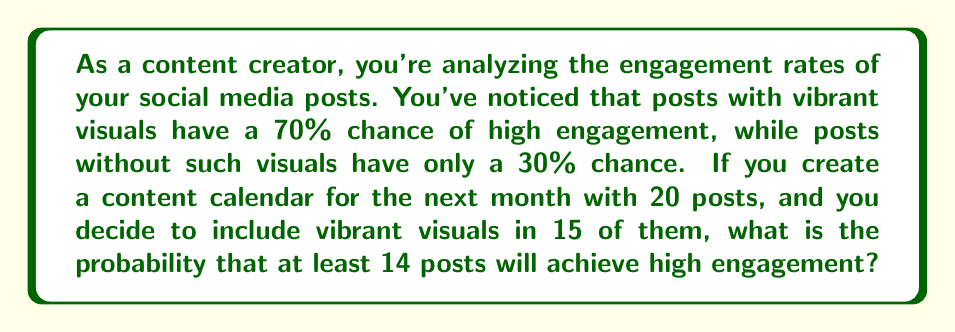Help me with this question. Let's approach this step-by-step using probability theory:

1) First, we need to recognize that this is a binomial probability problem. We have a fixed number of trials (20 posts) with two possible outcomes for each (high engagement or not), and we're looking for the probability of a certain number of successes (at least 14 high engagement posts).

2) Let's define our variables:
   $n = 20$ (total number of posts)
   $p_1 = 0.7$ (probability of high engagement for posts with vibrant visuals)
   $p_2 = 0.3$ (probability of high engagement for posts without vibrant visuals)
   $k \geq 14$ (we want at least 14 high engagement posts)

3) We have 15 posts with vibrant visuals and 5 without. We need to consider all possible combinations that lead to 14 or more high engagement posts.

4) We can use the binomial probability formula for each case and sum them:

   $$P(X \geq 14) = \sum_{i=14}^{20} P(X = i)$$

5) For each case, we need to consider the different ways to achieve i successes. For example, for 14 successes, we could have:
   - 14 from the 15 visual posts and 0 from the 5 non-visual posts
   - 13 from the 15 visual posts and 1 from the 5 non-visual posts
   - 12 from the 15 visual posts and 2 from the 5 non-visual posts
   ...and so on.

6) We can use the binomial probability formula for each of these subcases:

   $$P(X = k) = \binom{n_1}{k_1} p_1^{k_1} (1-p_1)^{n_1-k_1} \cdot \binom{n_2}{k_2} p_2^{k_2} (1-p_2)^{n_2-k_2}$$

   Where $n_1 = 15$, $n_2 = 5$, and $k_1 + k_2 = k$

7) Summing all these probabilities for $k = 14, 15, 16, 17, 18, 19, 20$ gives us our final answer.

8) This calculation is complex to do by hand, so typically we would use statistical software or a calculator with binomial probability functions to compute the result.
Answer: The probability that at least 14 posts will achieve high engagement is approximately 0.7373 or 73.73%. 